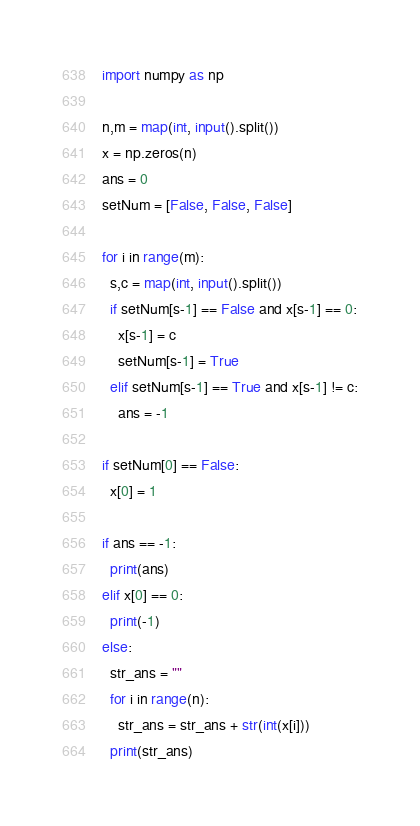Convert code to text. <code><loc_0><loc_0><loc_500><loc_500><_Python_>import numpy as np
 
n,m = map(int, input().split())
x = np.zeros(n)
ans = 0
setNum = [False, False, False]

for i in range(m):
  s,c = map(int, input().split())
  if setNum[s-1] == False and x[s-1] == 0:
    x[s-1] = c
    setNum[s-1] = True
  elif setNum[s-1] == True and x[s-1] != c:
    ans = -1

if setNum[0] == False:
  x[0] = 1
    
if ans == -1:
  print(ans)
elif x[0] == 0:
  print(-1)
else:
  str_ans = ""
  for i in range(n):
    str_ans = str_ans + str(int(x[i]))
  print(str_ans)</code> 